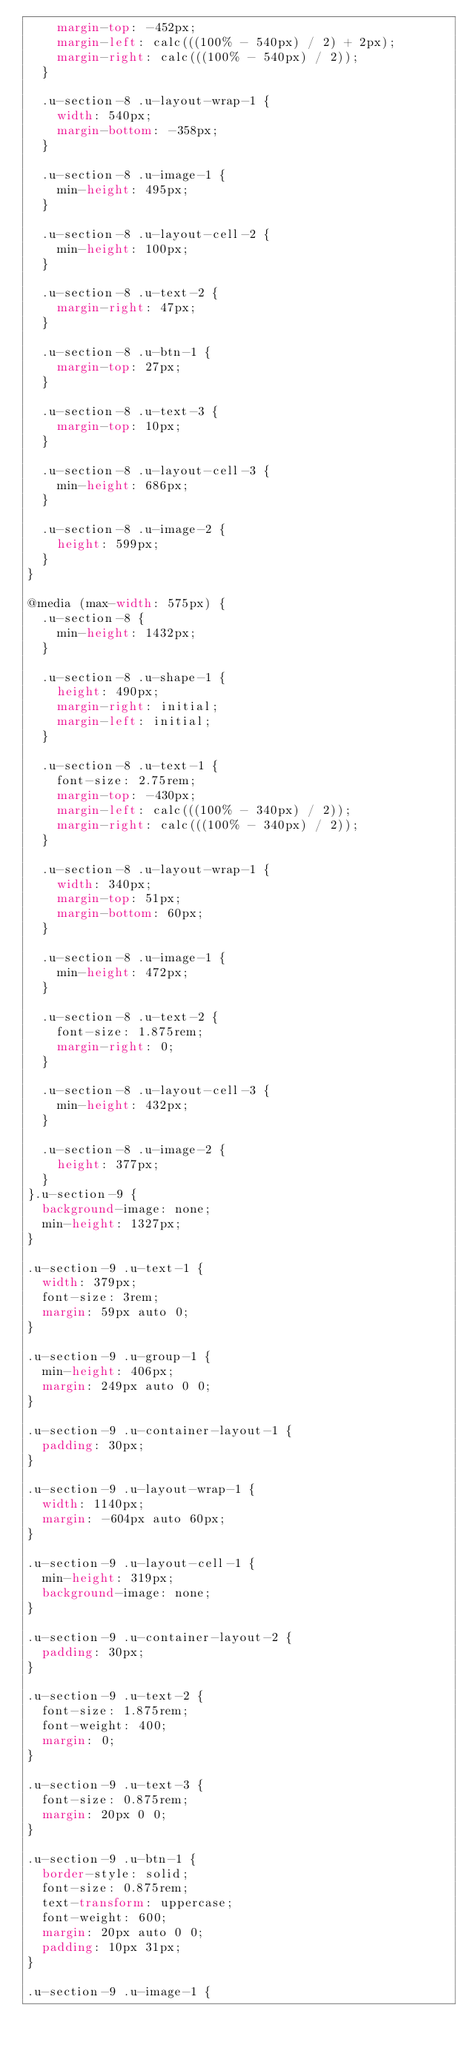<code> <loc_0><loc_0><loc_500><loc_500><_CSS_>    margin-top: -452px;
    margin-left: calc(((100% - 540px) / 2) + 2px);
    margin-right: calc(((100% - 540px) / 2));
  }

  .u-section-8 .u-layout-wrap-1 {
    width: 540px;
    margin-bottom: -358px;
  }

  .u-section-8 .u-image-1 {
    min-height: 495px;
  }

  .u-section-8 .u-layout-cell-2 {
    min-height: 100px;
  }

  .u-section-8 .u-text-2 {
    margin-right: 47px;
  }

  .u-section-8 .u-btn-1 {
    margin-top: 27px;
  }

  .u-section-8 .u-text-3 {
    margin-top: 10px;
  }

  .u-section-8 .u-layout-cell-3 {
    min-height: 686px;
  }

  .u-section-8 .u-image-2 {
    height: 599px;
  }
}

@media (max-width: 575px) {
  .u-section-8 {
    min-height: 1432px;
  }

  .u-section-8 .u-shape-1 {
    height: 490px;
    margin-right: initial;
    margin-left: initial;
  }

  .u-section-8 .u-text-1 {
    font-size: 2.75rem;
    margin-top: -430px;
    margin-left: calc(((100% - 340px) / 2));
    margin-right: calc(((100% - 340px) / 2));
  }

  .u-section-8 .u-layout-wrap-1 {
    width: 340px;
    margin-top: 51px;
    margin-bottom: 60px;
  }

  .u-section-8 .u-image-1 {
    min-height: 472px;
  }

  .u-section-8 .u-text-2 {
    font-size: 1.875rem;
    margin-right: 0;
  }

  .u-section-8 .u-layout-cell-3 {
    min-height: 432px;
  }

  .u-section-8 .u-image-2 {
    height: 377px;
  }
}.u-section-9 {
  background-image: none;
  min-height: 1327px;
}

.u-section-9 .u-text-1 {
  width: 379px;
  font-size: 3rem;
  margin: 59px auto 0;
}

.u-section-9 .u-group-1 {
  min-height: 406px;
  margin: 249px auto 0 0;
}

.u-section-9 .u-container-layout-1 {
  padding: 30px;
}

.u-section-9 .u-layout-wrap-1 {
  width: 1140px;
  margin: -604px auto 60px;
}

.u-section-9 .u-layout-cell-1 {
  min-height: 319px;
  background-image: none;
}

.u-section-9 .u-container-layout-2 {
  padding: 30px;
}

.u-section-9 .u-text-2 {
  font-size: 1.875rem;
  font-weight: 400;
  margin: 0;
}

.u-section-9 .u-text-3 {
  font-size: 0.875rem;
  margin: 20px 0 0;
}

.u-section-9 .u-btn-1 {
  border-style: solid;
  font-size: 0.875rem;
  text-transform: uppercase;
  font-weight: 600;
  margin: 20px auto 0 0;
  padding: 10px 31px;
}

.u-section-9 .u-image-1 {</code> 